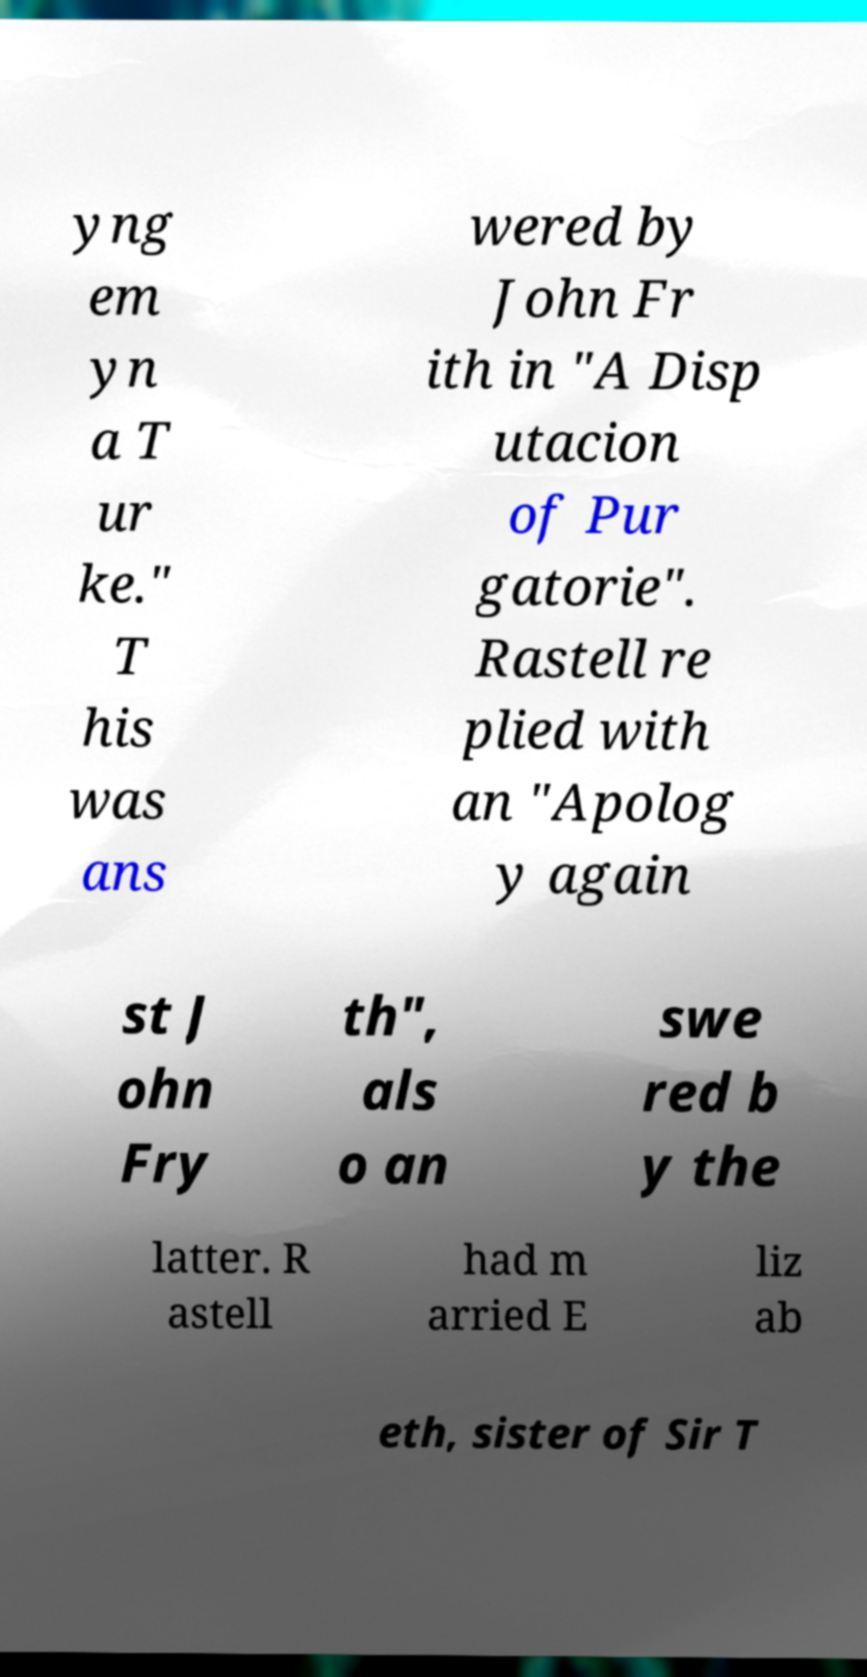Please identify and transcribe the text found in this image. yng em yn a T ur ke." T his was ans wered by John Fr ith in "A Disp utacion of Pur gatorie". Rastell re plied with an "Apolog y again st J ohn Fry th", als o an swe red b y the latter. R astell had m arried E liz ab eth, sister of Sir T 